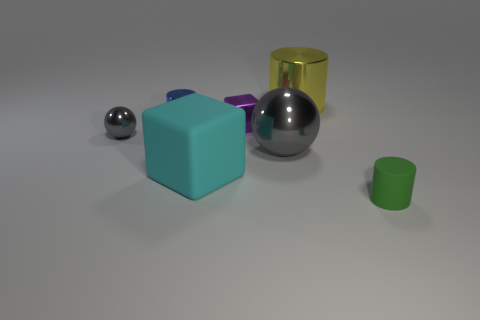Add 3 gray shiny balls. How many objects exist? 10 Subtract all spheres. How many objects are left? 5 Subtract all gray cylinders. Subtract all tiny blue cylinders. How many objects are left? 6 Add 5 cyan cubes. How many cyan cubes are left? 6 Add 4 large purple shiny balls. How many large purple shiny balls exist? 4 Subtract 0 gray blocks. How many objects are left? 7 